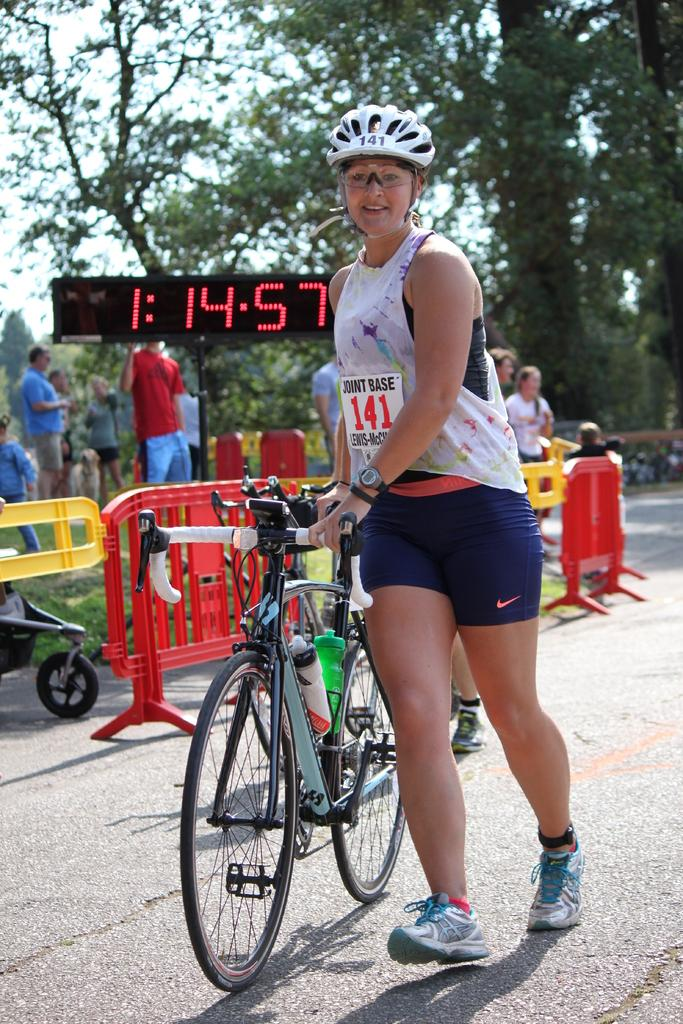What is the main subject of the image? The main subject of the image is a woman. What is the woman doing in the image? The woman is walking in the image. What is the woman holding while walking? The woman is holding a bicycle in the image. What safety equipment is the woman wearing? The woman is wearing a helmet in the image. What accessory is the woman wearing on her face? The woman is wearing spectacles in the image. What type of natural environment can be seen in the image? There are trees visible in the image. What man-made object displays the time in the image? There is a digital time board in the image. Are there any other people present in the image? Yes, there are people standing in the image. How many houses are visible in the image? There are no houses visible in the image. What type of thing is the woman using to walk on in the image? The woman is walking on the ground, not a specific "thing." 